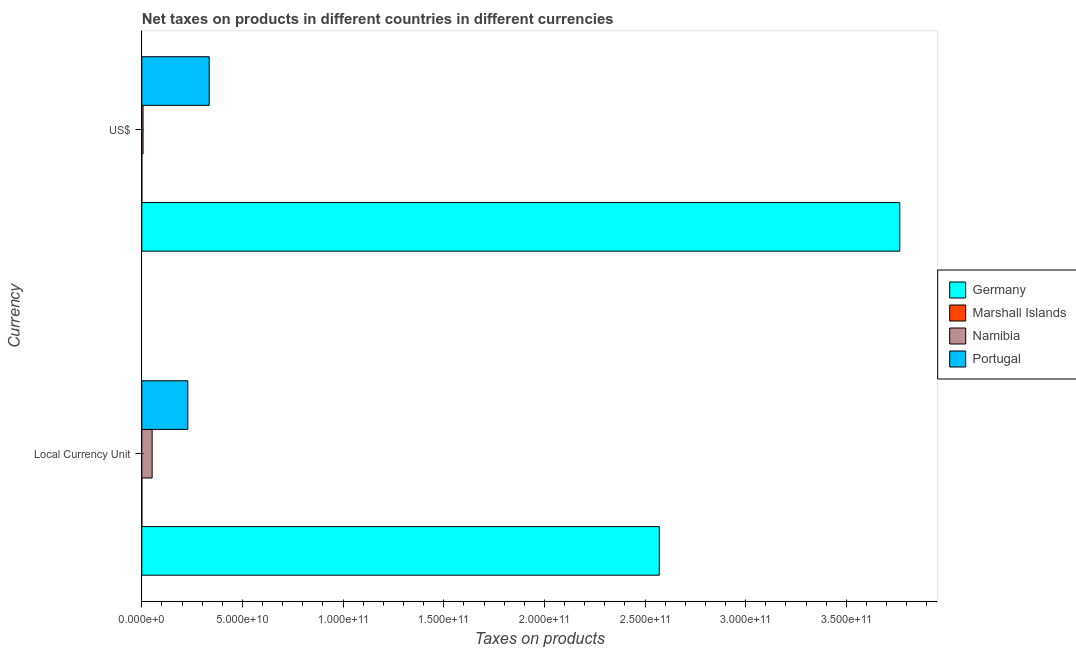How many groups of bars are there?
Offer a terse response. 2. How many bars are there on the 2nd tick from the top?
Offer a terse response. 4. How many bars are there on the 2nd tick from the bottom?
Offer a terse response. 4. What is the label of the 1st group of bars from the top?
Keep it short and to the point. US$. What is the net taxes in us$ in Germany?
Provide a short and direct response. 3.77e+11. Across all countries, what is the maximum net taxes in constant 2005 us$?
Offer a very short reply. 2.57e+11. Across all countries, what is the minimum net taxes in us$?
Offer a very short reply. 1.14e+07. In which country was the net taxes in constant 2005 us$ maximum?
Offer a very short reply. Germany. In which country was the net taxes in constant 2005 us$ minimum?
Offer a terse response. Marshall Islands. What is the total net taxes in us$ in the graph?
Your answer should be very brief. 4.11e+11. What is the difference between the net taxes in constant 2005 us$ in Marshall Islands and that in Portugal?
Provide a succinct answer. -2.28e+1. What is the difference between the net taxes in us$ in Marshall Islands and the net taxes in constant 2005 us$ in Germany?
Your answer should be compact. -2.57e+11. What is the average net taxes in constant 2005 us$ per country?
Provide a succinct answer. 7.13e+1. What is the difference between the net taxes in constant 2005 us$ and net taxes in us$ in Marshall Islands?
Your answer should be very brief. 0. What is the ratio of the net taxes in constant 2005 us$ in Germany to that in Marshall Islands?
Ensure brevity in your answer.  2.25e+04. What does the 1st bar from the top in US$ represents?
Offer a very short reply. Portugal. What does the 4th bar from the bottom in Local Currency Unit represents?
Ensure brevity in your answer.  Portugal. How many bars are there?
Your answer should be compact. 8. What is the difference between two consecutive major ticks on the X-axis?
Your answer should be compact. 5.00e+1. Does the graph contain grids?
Give a very brief answer. No. How are the legend labels stacked?
Your response must be concise. Vertical. What is the title of the graph?
Ensure brevity in your answer.  Net taxes on products in different countries in different currencies. Does "Kuwait" appear as one of the legend labels in the graph?
Offer a terse response. No. What is the label or title of the X-axis?
Ensure brevity in your answer.  Taxes on products. What is the label or title of the Y-axis?
Offer a terse response. Currency. What is the Taxes on products in Germany in Local Currency Unit?
Provide a succinct answer. 2.57e+11. What is the Taxes on products of Marshall Islands in Local Currency Unit?
Ensure brevity in your answer.  1.14e+07. What is the Taxes on products in Namibia in Local Currency Unit?
Offer a terse response. 5.14e+09. What is the Taxes on products of Portugal in Local Currency Unit?
Your answer should be compact. 2.29e+1. What is the Taxes on products in Germany in US$?
Your response must be concise. 3.77e+11. What is the Taxes on products in Marshall Islands in US$?
Your answer should be very brief. 1.14e+07. What is the Taxes on products of Namibia in US$?
Offer a terse response. 6.22e+08. What is the Taxes on products of Portugal in US$?
Your response must be concise. 3.35e+1. Across all Currency, what is the maximum Taxes on products of Germany?
Offer a very short reply. 3.77e+11. Across all Currency, what is the maximum Taxes on products of Marshall Islands?
Provide a succinct answer. 1.14e+07. Across all Currency, what is the maximum Taxes on products in Namibia?
Your response must be concise. 5.14e+09. Across all Currency, what is the maximum Taxes on products in Portugal?
Keep it short and to the point. 3.35e+1. Across all Currency, what is the minimum Taxes on products of Germany?
Make the answer very short. 2.57e+11. Across all Currency, what is the minimum Taxes on products in Marshall Islands?
Keep it short and to the point. 1.14e+07. Across all Currency, what is the minimum Taxes on products of Namibia?
Your answer should be very brief. 6.22e+08. Across all Currency, what is the minimum Taxes on products of Portugal?
Provide a succinct answer. 2.29e+1. What is the total Taxes on products in Germany in the graph?
Your answer should be very brief. 6.34e+11. What is the total Taxes on products of Marshall Islands in the graph?
Ensure brevity in your answer.  2.29e+07. What is the total Taxes on products of Namibia in the graph?
Offer a terse response. 5.76e+09. What is the total Taxes on products of Portugal in the graph?
Your response must be concise. 5.63e+1. What is the difference between the Taxes on products of Germany in Local Currency Unit and that in US$?
Offer a very short reply. -1.19e+11. What is the difference between the Taxes on products of Namibia in Local Currency Unit and that in US$?
Offer a terse response. 4.52e+09. What is the difference between the Taxes on products in Portugal in Local Currency Unit and that in US$?
Offer a terse response. -1.06e+1. What is the difference between the Taxes on products of Germany in Local Currency Unit and the Taxes on products of Marshall Islands in US$?
Provide a succinct answer. 2.57e+11. What is the difference between the Taxes on products in Germany in Local Currency Unit and the Taxes on products in Namibia in US$?
Offer a very short reply. 2.56e+11. What is the difference between the Taxes on products in Germany in Local Currency Unit and the Taxes on products in Portugal in US$?
Ensure brevity in your answer.  2.24e+11. What is the difference between the Taxes on products of Marshall Islands in Local Currency Unit and the Taxes on products of Namibia in US$?
Give a very brief answer. -6.10e+08. What is the difference between the Taxes on products of Marshall Islands in Local Currency Unit and the Taxes on products of Portugal in US$?
Provide a short and direct response. -3.35e+1. What is the difference between the Taxes on products of Namibia in Local Currency Unit and the Taxes on products of Portugal in US$?
Make the answer very short. -2.83e+1. What is the average Taxes on products of Germany per Currency?
Make the answer very short. 3.17e+11. What is the average Taxes on products in Marshall Islands per Currency?
Your response must be concise. 1.14e+07. What is the average Taxes on products of Namibia per Currency?
Ensure brevity in your answer.  2.88e+09. What is the average Taxes on products in Portugal per Currency?
Offer a very short reply. 2.82e+1. What is the difference between the Taxes on products in Germany and Taxes on products in Marshall Islands in Local Currency Unit?
Provide a succinct answer. 2.57e+11. What is the difference between the Taxes on products in Germany and Taxes on products in Namibia in Local Currency Unit?
Your response must be concise. 2.52e+11. What is the difference between the Taxes on products of Germany and Taxes on products of Portugal in Local Currency Unit?
Give a very brief answer. 2.34e+11. What is the difference between the Taxes on products of Marshall Islands and Taxes on products of Namibia in Local Currency Unit?
Offer a very short reply. -5.13e+09. What is the difference between the Taxes on products of Marshall Islands and Taxes on products of Portugal in Local Currency Unit?
Keep it short and to the point. -2.28e+1. What is the difference between the Taxes on products in Namibia and Taxes on products in Portugal in Local Currency Unit?
Offer a terse response. -1.77e+1. What is the difference between the Taxes on products in Germany and Taxes on products in Marshall Islands in US$?
Give a very brief answer. 3.77e+11. What is the difference between the Taxes on products in Germany and Taxes on products in Namibia in US$?
Provide a succinct answer. 3.76e+11. What is the difference between the Taxes on products in Germany and Taxes on products in Portugal in US$?
Your response must be concise. 3.43e+11. What is the difference between the Taxes on products in Marshall Islands and Taxes on products in Namibia in US$?
Your answer should be compact. -6.10e+08. What is the difference between the Taxes on products of Marshall Islands and Taxes on products of Portugal in US$?
Your response must be concise. -3.35e+1. What is the difference between the Taxes on products in Namibia and Taxes on products in Portugal in US$?
Your answer should be very brief. -3.29e+1. What is the ratio of the Taxes on products of Germany in Local Currency Unit to that in US$?
Your response must be concise. 0.68. What is the ratio of the Taxes on products of Namibia in Local Currency Unit to that in US$?
Keep it short and to the point. 8.26. What is the ratio of the Taxes on products in Portugal in Local Currency Unit to that in US$?
Your answer should be very brief. 0.68. What is the difference between the highest and the second highest Taxes on products in Germany?
Provide a succinct answer. 1.19e+11. What is the difference between the highest and the second highest Taxes on products of Namibia?
Ensure brevity in your answer.  4.52e+09. What is the difference between the highest and the second highest Taxes on products in Portugal?
Your answer should be compact. 1.06e+1. What is the difference between the highest and the lowest Taxes on products of Germany?
Provide a succinct answer. 1.19e+11. What is the difference between the highest and the lowest Taxes on products in Namibia?
Offer a very short reply. 4.52e+09. What is the difference between the highest and the lowest Taxes on products in Portugal?
Offer a very short reply. 1.06e+1. 